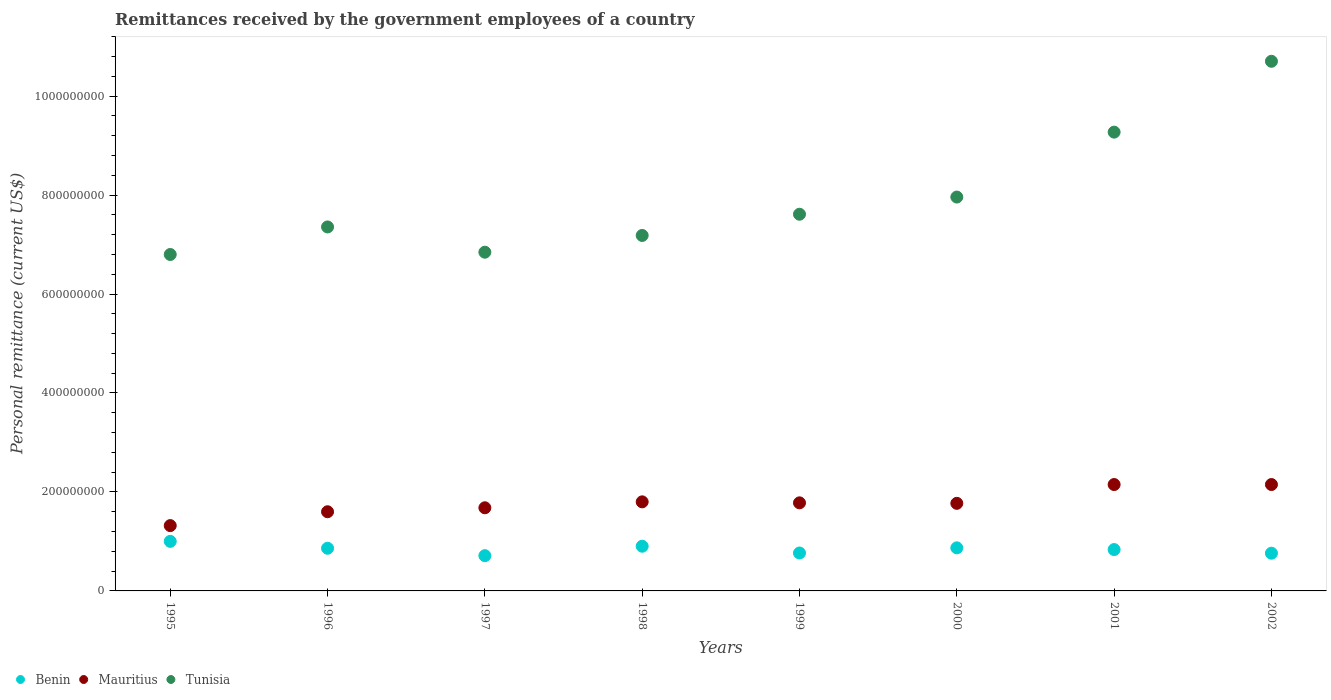How many different coloured dotlines are there?
Make the answer very short. 3. What is the remittances received by the government employees in Benin in 1998?
Offer a very short reply. 9.03e+07. Across all years, what is the maximum remittances received by the government employees in Mauritius?
Offer a terse response. 2.15e+08. Across all years, what is the minimum remittances received by the government employees in Mauritius?
Make the answer very short. 1.32e+08. In which year was the remittances received by the government employees in Benin minimum?
Make the answer very short. 1997. What is the total remittances received by the government employees in Mauritius in the graph?
Your response must be concise. 1.42e+09. What is the difference between the remittances received by the government employees in Tunisia in 1997 and that in 2001?
Keep it short and to the point. -2.43e+08. What is the difference between the remittances received by the government employees in Benin in 1995 and the remittances received by the government employees in Tunisia in 1996?
Offer a very short reply. -6.35e+08. What is the average remittances received by the government employees in Tunisia per year?
Make the answer very short. 7.97e+08. In the year 1998, what is the difference between the remittances received by the government employees in Mauritius and remittances received by the government employees in Tunisia?
Your answer should be compact. -5.38e+08. In how many years, is the remittances received by the government employees in Mauritius greater than 360000000 US$?
Offer a terse response. 0. What is the ratio of the remittances received by the government employees in Mauritius in 1995 to that in 1999?
Provide a succinct answer. 0.74. Is the difference between the remittances received by the government employees in Mauritius in 1999 and 2001 greater than the difference between the remittances received by the government employees in Tunisia in 1999 and 2001?
Your answer should be very brief. Yes. What is the difference between the highest and the second highest remittances received by the government employees in Benin?
Keep it short and to the point. 9.81e+06. What is the difference between the highest and the lowest remittances received by the government employees in Mauritius?
Offer a very short reply. 8.30e+07. In how many years, is the remittances received by the government employees in Benin greater than the average remittances received by the government employees in Benin taken over all years?
Offer a very short reply. 4. Is the remittances received by the government employees in Mauritius strictly greater than the remittances received by the government employees in Tunisia over the years?
Make the answer very short. No. Are the values on the major ticks of Y-axis written in scientific E-notation?
Ensure brevity in your answer.  No. Does the graph contain any zero values?
Give a very brief answer. No. Does the graph contain grids?
Offer a very short reply. No. Where does the legend appear in the graph?
Offer a very short reply. Bottom left. How many legend labels are there?
Offer a terse response. 3. How are the legend labels stacked?
Ensure brevity in your answer.  Horizontal. What is the title of the graph?
Offer a terse response. Remittances received by the government employees of a country. What is the label or title of the Y-axis?
Make the answer very short. Personal remittance (current US$). What is the Personal remittance (current US$) in Benin in 1995?
Offer a terse response. 1.00e+08. What is the Personal remittance (current US$) of Mauritius in 1995?
Offer a very short reply. 1.32e+08. What is the Personal remittance (current US$) of Tunisia in 1995?
Your answer should be compact. 6.80e+08. What is the Personal remittance (current US$) of Benin in 1996?
Your answer should be very brief. 8.62e+07. What is the Personal remittance (current US$) of Mauritius in 1996?
Keep it short and to the point. 1.60e+08. What is the Personal remittance (current US$) in Tunisia in 1996?
Make the answer very short. 7.36e+08. What is the Personal remittance (current US$) in Benin in 1997?
Give a very brief answer. 7.12e+07. What is the Personal remittance (current US$) of Mauritius in 1997?
Make the answer very short. 1.68e+08. What is the Personal remittance (current US$) of Tunisia in 1997?
Offer a very short reply. 6.85e+08. What is the Personal remittance (current US$) in Benin in 1998?
Offer a very short reply. 9.03e+07. What is the Personal remittance (current US$) in Mauritius in 1998?
Make the answer very short. 1.80e+08. What is the Personal remittance (current US$) in Tunisia in 1998?
Provide a short and direct response. 7.18e+08. What is the Personal remittance (current US$) in Benin in 1999?
Your answer should be very brief. 7.66e+07. What is the Personal remittance (current US$) of Mauritius in 1999?
Provide a short and direct response. 1.78e+08. What is the Personal remittance (current US$) in Tunisia in 1999?
Ensure brevity in your answer.  7.61e+08. What is the Personal remittance (current US$) in Benin in 2000?
Your answer should be compact. 8.71e+07. What is the Personal remittance (current US$) of Mauritius in 2000?
Provide a short and direct response. 1.77e+08. What is the Personal remittance (current US$) in Tunisia in 2000?
Make the answer very short. 7.96e+08. What is the Personal remittance (current US$) of Benin in 2001?
Your answer should be compact. 8.36e+07. What is the Personal remittance (current US$) of Mauritius in 2001?
Offer a very short reply. 2.15e+08. What is the Personal remittance (current US$) in Tunisia in 2001?
Your answer should be very brief. 9.27e+08. What is the Personal remittance (current US$) of Benin in 2002?
Your answer should be compact. 7.62e+07. What is the Personal remittance (current US$) of Mauritius in 2002?
Give a very brief answer. 2.15e+08. What is the Personal remittance (current US$) in Tunisia in 2002?
Your answer should be very brief. 1.07e+09. Across all years, what is the maximum Personal remittance (current US$) in Benin?
Offer a very short reply. 1.00e+08. Across all years, what is the maximum Personal remittance (current US$) in Mauritius?
Provide a short and direct response. 2.15e+08. Across all years, what is the maximum Personal remittance (current US$) of Tunisia?
Offer a very short reply. 1.07e+09. Across all years, what is the minimum Personal remittance (current US$) in Benin?
Give a very brief answer. 7.12e+07. Across all years, what is the minimum Personal remittance (current US$) of Mauritius?
Offer a terse response. 1.32e+08. Across all years, what is the minimum Personal remittance (current US$) in Tunisia?
Offer a very short reply. 6.80e+08. What is the total Personal remittance (current US$) in Benin in the graph?
Your answer should be compact. 6.71e+08. What is the total Personal remittance (current US$) in Mauritius in the graph?
Make the answer very short. 1.42e+09. What is the total Personal remittance (current US$) in Tunisia in the graph?
Offer a terse response. 6.37e+09. What is the difference between the Personal remittance (current US$) of Benin in 1995 and that in 1996?
Offer a terse response. 1.39e+07. What is the difference between the Personal remittance (current US$) in Mauritius in 1995 and that in 1996?
Your answer should be very brief. -2.80e+07. What is the difference between the Personal remittance (current US$) of Tunisia in 1995 and that in 1996?
Your answer should be very brief. -5.57e+07. What is the difference between the Personal remittance (current US$) in Benin in 1995 and that in 1997?
Offer a terse response. 2.89e+07. What is the difference between the Personal remittance (current US$) in Mauritius in 1995 and that in 1997?
Offer a very short reply. -3.60e+07. What is the difference between the Personal remittance (current US$) in Tunisia in 1995 and that in 1997?
Your response must be concise. -4.62e+06. What is the difference between the Personal remittance (current US$) of Benin in 1995 and that in 1998?
Give a very brief answer. 9.81e+06. What is the difference between the Personal remittance (current US$) of Mauritius in 1995 and that in 1998?
Offer a terse response. -4.80e+07. What is the difference between the Personal remittance (current US$) in Tunisia in 1995 and that in 1998?
Offer a very short reply. -3.85e+07. What is the difference between the Personal remittance (current US$) of Benin in 1995 and that in 1999?
Provide a short and direct response. 2.35e+07. What is the difference between the Personal remittance (current US$) of Mauritius in 1995 and that in 1999?
Your answer should be compact. -4.60e+07. What is the difference between the Personal remittance (current US$) in Tunisia in 1995 and that in 1999?
Ensure brevity in your answer.  -8.14e+07. What is the difference between the Personal remittance (current US$) in Benin in 1995 and that in 2000?
Your answer should be compact. 1.31e+07. What is the difference between the Personal remittance (current US$) in Mauritius in 1995 and that in 2000?
Give a very brief answer. -4.50e+07. What is the difference between the Personal remittance (current US$) of Tunisia in 1995 and that in 2000?
Make the answer very short. -1.16e+08. What is the difference between the Personal remittance (current US$) of Benin in 1995 and that in 2001?
Offer a terse response. 1.65e+07. What is the difference between the Personal remittance (current US$) in Mauritius in 1995 and that in 2001?
Offer a terse response. -8.30e+07. What is the difference between the Personal remittance (current US$) in Tunisia in 1995 and that in 2001?
Your response must be concise. -2.47e+08. What is the difference between the Personal remittance (current US$) of Benin in 1995 and that in 2002?
Make the answer very short. 2.39e+07. What is the difference between the Personal remittance (current US$) in Mauritius in 1995 and that in 2002?
Offer a very short reply. -8.30e+07. What is the difference between the Personal remittance (current US$) in Tunisia in 1995 and that in 2002?
Give a very brief answer. -3.90e+08. What is the difference between the Personal remittance (current US$) of Benin in 1996 and that in 1997?
Your answer should be compact. 1.50e+07. What is the difference between the Personal remittance (current US$) in Mauritius in 1996 and that in 1997?
Offer a very short reply. -8.00e+06. What is the difference between the Personal remittance (current US$) in Tunisia in 1996 and that in 1997?
Offer a terse response. 5.11e+07. What is the difference between the Personal remittance (current US$) of Benin in 1996 and that in 1998?
Offer a very short reply. -4.12e+06. What is the difference between the Personal remittance (current US$) of Mauritius in 1996 and that in 1998?
Your response must be concise. -2.00e+07. What is the difference between the Personal remittance (current US$) in Tunisia in 1996 and that in 1998?
Your response must be concise. 1.72e+07. What is the difference between the Personal remittance (current US$) of Benin in 1996 and that in 1999?
Your answer should be compact. 9.56e+06. What is the difference between the Personal remittance (current US$) of Mauritius in 1996 and that in 1999?
Offer a very short reply. -1.80e+07. What is the difference between the Personal remittance (current US$) in Tunisia in 1996 and that in 1999?
Ensure brevity in your answer.  -2.57e+07. What is the difference between the Personal remittance (current US$) in Benin in 1996 and that in 2000?
Keep it short and to the point. -8.57e+05. What is the difference between the Personal remittance (current US$) in Mauritius in 1996 and that in 2000?
Your answer should be very brief. -1.70e+07. What is the difference between the Personal remittance (current US$) of Tunisia in 1996 and that in 2000?
Your response must be concise. -6.04e+07. What is the difference between the Personal remittance (current US$) in Benin in 1996 and that in 2001?
Provide a short and direct response. 2.61e+06. What is the difference between the Personal remittance (current US$) in Mauritius in 1996 and that in 2001?
Offer a terse response. -5.50e+07. What is the difference between the Personal remittance (current US$) in Tunisia in 1996 and that in 2001?
Your answer should be compact. -1.92e+08. What is the difference between the Personal remittance (current US$) in Benin in 1996 and that in 2002?
Give a very brief answer. 9.98e+06. What is the difference between the Personal remittance (current US$) of Mauritius in 1996 and that in 2002?
Provide a short and direct response. -5.50e+07. What is the difference between the Personal remittance (current US$) in Tunisia in 1996 and that in 2002?
Provide a short and direct response. -3.35e+08. What is the difference between the Personal remittance (current US$) of Benin in 1997 and that in 1998?
Make the answer very short. -1.91e+07. What is the difference between the Personal remittance (current US$) of Mauritius in 1997 and that in 1998?
Your answer should be compact. -1.20e+07. What is the difference between the Personal remittance (current US$) in Tunisia in 1997 and that in 1998?
Give a very brief answer. -3.38e+07. What is the difference between the Personal remittance (current US$) of Benin in 1997 and that in 1999?
Make the answer very short. -5.41e+06. What is the difference between the Personal remittance (current US$) in Mauritius in 1997 and that in 1999?
Ensure brevity in your answer.  -1.00e+07. What is the difference between the Personal remittance (current US$) in Tunisia in 1997 and that in 1999?
Offer a very short reply. -7.67e+07. What is the difference between the Personal remittance (current US$) in Benin in 1997 and that in 2000?
Keep it short and to the point. -1.58e+07. What is the difference between the Personal remittance (current US$) of Mauritius in 1997 and that in 2000?
Offer a very short reply. -9.00e+06. What is the difference between the Personal remittance (current US$) in Tunisia in 1997 and that in 2000?
Ensure brevity in your answer.  -1.11e+08. What is the difference between the Personal remittance (current US$) in Benin in 1997 and that in 2001?
Provide a short and direct response. -1.24e+07. What is the difference between the Personal remittance (current US$) of Mauritius in 1997 and that in 2001?
Offer a very short reply. -4.70e+07. What is the difference between the Personal remittance (current US$) in Tunisia in 1997 and that in 2001?
Provide a succinct answer. -2.43e+08. What is the difference between the Personal remittance (current US$) in Benin in 1997 and that in 2002?
Keep it short and to the point. -4.99e+06. What is the difference between the Personal remittance (current US$) of Mauritius in 1997 and that in 2002?
Keep it short and to the point. -4.70e+07. What is the difference between the Personal remittance (current US$) in Tunisia in 1997 and that in 2002?
Give a very brief answer. -3.86e+08. What is the difference between the Personal remittance (current US$) in Benin in 1998 and that in 1999?
Provide a succinct answer. 1.37e+07. What is the difference between the Personal remittance (current US$) of Mauritius in 1998 and that in 1999?
Give a very brief answer. 2.00e+06. What is the difference between the Personal remittance (current US$) in Tunisia in 1998 and that in 1999?
Give a very brief answer. -4.29e+07. What is the difference between the Personal remittance (current US$) of Benin in 1998 and that in 2000?
Your answer should be compact. 3.26e+06. What is the difference between the Personal remittance (current US$) in Tunisia in 1998 and that in 2000?
Your answer should be very brief. -7.76e+07. What is the difference between the Personal remittance (current US$) in Benin in 1998 and that in 2001?
Provide a short and direct response. 6.72e+06. What is the difference between the Personal remittance (current US$) of Mauritius in 1998 and that in 2001?
Your response must be concise. -3.50e+07. What is the difference between the Personal remittance (current US$) in Tunisia in 1998 and that in 2001?
Provide a short and direct response. -2.09e+08. What is the difference between the Personal remittance (current US$) of Benin in 1998 and that in 2002?
Offer a terse response. 1.41e+07. What is the difference between the Personal remittance (current US$) of Mauritius in 1998 and that in 2002?
Offer a terse response. -3.50e+07. What is the difference between the Personal remittance (current US$) of Tunisia in 1998 and that in 2002?
Your response must be concise. -3.52e+08. What is the difference between the Personal remittance (current US$) in Benin in 1999 and that in 2000?
Offer a very short reply. -1.04e+07. What is the difference between the Personal remittance (current US$) of Tunisia in 1999 and that in 2000?
Make the answer very short. -3.47e+07. What is the difference between the Personal remittance (current US$) in Benin in 1999 and that in 2001?
Offer a terse response. -6.95e+06. What is the difference between the Personal remittance (current US$) in Mauritius in 1999 and that in 2001?
Provide a succinct answer. -3.70e+07. What is the difference between the Personal remittance (current US$) in Tunisia in 1999 and that in 2001?
Your answer should be very brief. -1.66e+08. What is the difference between the Personal remittance (current US$) of Benin in 1999 and that in 2002?
Offer a very short reply. 4.17e+05. What is the difference between the Personal remittance (current US$) in Mauritius in 1999 and that in 2002?
Offer a very short reply. -3.70e+07. What is the difference between the Personal remittance (current US$) of Tunisia in 1999 and that in 2002?
Your response must be concise. -3.09e+08. What is the difference between the Personal remittance (current US$) in Benin in 2000 and that in 2001?
Provide a succinct answer. 3.46e+06. What is the difference between the Personal remittance (current US$) of Mauritius in 2000 and that in 2001?
Your answer should be very brief. -3.80e+07. What is the difference between the Personal remittance (current US$) of Tunisia in 2000 and that in 2001?
Offer a terse response. -1.31e+08. What is the difference between the Personal remittance (current US$) of Benin in 2000 and that in 2002?
Offer a terse response. 1.08e+07. What is the difference between the Personal remittance (current US$) in Mauritius in 2000 and that in 2002?
Offer a very short reply. -3.80e+07. What is the difference between the Personal remittance (current US$) of Tunisia in 2000 and that in 2002?
Provide a short and direct response. -2.74e+08. What is the difference between the Personal remittance (current US$) in Benin in 2001 and that in 2002?
Offer a terse response. 7.37e+06. What is the difference between the Personal remittance (current US$) in Mauritius in 2001 and that in 2002?
Keep it short and to the point. 0. What is the difference between the Personal remittance (current US$) in Tunisia in 2001 and that in 2002?
Provide a succinct answer. -1.43e+08. What is the difference between the Personal remittance (current US$) of Benin in 1995 and the Personal remittance (current US$) of Mauritius in 1996?
Ensure brevity in your answer.  -5.99e+07. What is the difference between the Personal remittance (current US$) of Benin in 1995 and the Personal remittance (current US$) of Tunisia in 1996?
Offer a terse response. -6.35e+08. What is the difference between the Personal remittance (current US$) in Mauritius in 1995 and the Personal remittance (current US$) in Tunisia in 1996?
Your answer should be very brief. -6.04e+08. What is the difference between the Personal remittance (current US$) in Benin in 1995 and the Personal remittance (current US$) in Mauritius in 1997?
Provide a succinct answer. -6.79e+07. What is the difference between the Personal remittance (current US$) in Benin in 1995 and the Personal remittance (current US$) in Tunisia in 1997?
Make the answer very short. -5.84e+08. What is the difference between the Personal remittance (current US$) of Mauritius in 1995 and the Personal remittance (current US$) of Tunisia in 1997?
Offer a very short reply. -5.53e+08. What is the difference between the Personal remittance (current US$) in Benin in 1995 and the Personal remittance (current US$) in Mauritius in 1998?
Provide a succinct answer. -7.99e+07. What is the difference between the Personal remittance (current US$) in Benin in 1995 and the Personal remittance (current US$) in Tunisia in 1998?
Your response must be concise. -6.18e+08. What is the difference between the Personal remittance (current US$) of Mauritius in 1995 and the Personal remittance (current US$) of Tunisia in 1998?
Give a very brief answer. -5.86e+08. What is the difference between the Personal remittance (current US$) in Benin in 1995 and the Personal remittance (current US$) in Mauritius in 1999?
Provide a short and direct response. -7.79e+07. What is the difference between the Personal remittance (current US$) in Benin in 1995 and the Personal remittance (current US$) in Tunisia in 1999?
Give a very brief answer. -6.61e+08. What is the difference between the Personal remittance (current US$) of Mauritius in 1995 and the Personal remittance (current US$) of Tunisia in 1999?
Keep it short and to the point. -6.29e+08. What is the difference between the Personal remittance (current US$) of Benin in 1995 and the Personal remittance (current US$) of Mauritius in 2000?
Give a very brief answer. -7.69e+07. What is the difference between the Personal remittance (current US$) of Benin in 1995 and the Personal remittance (current US$) of Tunisia in 2000?
Your answer should be very brief. -6.96e+08. What is the difference between the Personal remittance (current US$) in Mauritius in 1995 and the Personal remittance (current US$) in Tunisia in 2000?
Provide a succinct answer. -6.64e+08. What is the difference between the Personal remittance (current US$) of Benin in 1995 and the Personal remittance (current US$) of Mauritius in 2001?
Your response must be concise. -1.15e+08. What is the difference between the Personal remittance (current US$) of Benin in 1995 and the Personal remittance (current US$) of Tunisia in 2001?
Offer a terse response. -8.27e+08. What is the difference between the Personal remittance (current US$) of Mauritius in 1995 and the Personal remittance (current US$) of Tunisia in 2001?
Your response must be concise. -7.95e+08. What is the difference between the Personal remittance (current US$) in Benin in 1995 and the Personal remittance (current US$) in Mauritius in 2002?
Keep it short and to the point. -1.15e+08. What is the difference between the Personal remittance (current US$) in Benin in 1995 and the Personal remittance (current US$) in Tunisia in 2002?
Provide a short and direct response. -9.70e+08. What is the difference between the Personal remittance (current US$) in Mauritius in 1995 and the Personal remittance (current US$) in Tunisia in 2002?
Make the answer very short. -9.38e+08. What is the difference between the Personal remittance (current US$) in Benin in 1996 and the Personal remittance (current US$) in Mauritius in 1997?
Offer a very short reply. -8.18e+07. What is the difference between the Personal remittance (current US$) in Benin in 1996 and the Personal remittance (current US$) in Tunisia in 1997?
Keep it short and to the point. -5.98e+08. What is the difference between the Personal remittance (current US$) of Mauritius in 1996 and the Personal remittance (current US$) of Tunisia in 1997?
Your answer should be very brief. -5.25e+08. What is the difference between the Personal remittance (current US$) of Benin in 1996 and the Personal remittance (current US$) of Mauritius in 1998?
Offer a terse response. -9.38e+07. What is the difference between the Personal remittance (current US$) of Benin in 1996 and the Personal remittance (current US$) of Tunisia in 1998?
Offer a very short reply. -6.32e+08. What is the difference between the Personal remittance (current US$) in Mauritius in 1996 and the Personal remittance (current US$) in Tunisia in 1998?
Your response must be concise. -5.58e+08. What is the difference between the Personal remittance (current US$) in Benin in 1996 and the Personal remittance (current US$) in Mauritius in 1999?
Your answer should be very brief. -9.18e+07. What is the difference between the Personal remittance (current US$) of Benin in 1996 and the Personal remittance (current US$) of Tunisia in 1999?
Give a very brief answer. -6.75e+08. What is the difference between the Personal remittance (current US$) in Mauritius in 1996 and the Personal remittance (current US$) in Tunisia in 1999?
Give a very brief answer. -6.01e+08. What is the difference between the Personal remittance (current US$) of Benin in 1996 and the Personal remittance (current US$) of Mauritius in 2000?
Ensure brevity in your answer.  -9.08e+07. What is the difference between the Personal remittance (current US$) of Benin in 1996 and the Personal remittance (current US$) of Tunisia in 2000?
Ensure brevity in your answer.  -7.10e+08. What is the difference between the Personal remittance (current US$) in Mauritius in 1996 and the Personal remittance (current US$) in Tunisia in 2000?
Ensure brevity in your answer.  -6.36e+08. What is the difference between the Personal remittance (current US$) in Benin in 1996 and the Personal remittance (current US$) in Mauritius in 2001?
Your answer should be very brief. -1.29e+08. What is the difference between the Personal remittance (current US$) of Benin in 1996 and the Personal remittance (current US$) of Tunisia in 2001?
Give a very brief answer. -8.41e+08. What is the difference between the Personal remittance (current US$) of Mauritius in 1996 and the Personal remittance (current US$) of Tunisia in 2001?
Provide a succinct answer. -7.67e+08. What is the difference between the Personal remittance (current US$) of Benin in 1996 and the Personal remittance (current US$) of Mauritius in 2002?
Make the answer very short. -1.29e+08. What is the difference between the Personal remittance (current US$) in Benin in 1996 and the Personal remittance (current US$) in Tunisia in 2002?
Provide a succinct answer. -9.84e+08. What is the difference between the Personal remittance (current US$) of Mauritius in 1996 and the Personal remittance (current US$) of Tunisia in 2002?
Offer a very short reply. -9.10e+08. What is the difference between the Personal remittance (current US$) in Benin in 1997 and the Personal remittance (current US$) in Mauritius in 1998?
Provide a short and direct response. -1.09e+08. What is the difference between the Personal remittance (current US$) of Benin in 1997 and the Personal remittance (current US$) of Tunisia in 1998?
Keep it short and to the point. -6.47e+08. What is the difference between the Personal remittance (current US$) of Mauritius in 1997 and the Personal remittance (current US$) of Tunisia in 1998?
Give a very brief answer. -5.50e+08. What is the difference between the Personal remittance (current US$) in Benin in 1997 and the Personal remittance (current US$) in Mauritius in 1999?
Provide a succinct answer. -1.07e+08. What is the difference between the Personal remittance (current US$) of Benin in 1997 and the Personal remittance (current US$) of Tunisia in 1999?
Offer a terse response. -6.90e+08. What is the difference between the Personal remittance (current US$) in Mauritius in 1997 and the Personal remittance (current US$) in Tunisia in 1999?
Your answer should be very brief. -5.93e+08. What is the difference between the Personal remittance (current US$) of Benin in 1997 and the Personal remittance (current US$) of Mauritius in 2000?
Your response must be concise. -1.06e+08. What is the difference between the Personal remittance (current US$) in Benin in 1997 and the Personal remittance (current US$) in Tunisia in 2000?
Provide a succinct answer. -7.25e+08. What is the difference between the Personal remittance (current US$) of Mauritius in 1997 and the Personal remittance (current US$) of Tunisia in 2000?
Your answer should be very brief. -6.28e+08. What is the difference between the Personal remittance (current US$) of Benin in 1997 and the Personal remittance (current US$) of Mauritius in 2001?
Your answer should be very brief. -1.44e+08. What is the difference between the Personal remittance (current US$) of Benin in 1997 and the Personal remittance (current US$) of Tunisia in 2001?
Provide a short and direct response. -8.56e+08. What is the difference between the Personal remittance (current US$) in Mauritius in 1997 and the Personal remittance (current US$) in Tunisia in 2001?
Offer a very short reply. -7.59e+08. What is the difference between the Personal remittance (current US$) in Benin in 1997 and the Personal remittance (current US$) in Mauritius in 2002?
Keep it short and to the point. -1.44e+08. What is the difference between the Personal remittance (current US$) of Benin in 1997 and the Personal remittance (current US$) of Tunisia in 2002?
Offer a very short reply. -9.99e+08. What is the difference between the Personal remittance (current US$) of Mauritius in 1997 and the Personal remittance (current US$) of Tunisia in 2002?
Your answer should be compact. -9.02e+08. What is the difference between the Personal remittance (current US$) in Benin in 1998 and the Personal remittance (current US$) in Mauritius in 1999?
Your answer should be compact. -8.77e+07. What is the difference between the Personal remittance (current US$) in Benin in 1998 and the Personal remittance (current US$) in Tunisia in 1999?
Offer a very short reply. -6.71e+08. What is the difference between the Personal remittance (current US$) of Mauritius in 1998 and the Personal remittance (current US$) of Tunisia in 1999?
Your answer should be compact. -5.81e+08. What is the difference between the Personal remittance (current US$) of Benin in 1998 and the Personal remittance (current US$) of Mauritius in 2000?
Your answer should be very brief. -8.67e+07. What is the difference between the Personal remittance (current US$) in Benin in 1998 and the Personal remittance (current US$) in Tunisia in 2000?
Provide a succinct answer. -7.06e+08. What is the difference between the Personal remittance (current US$) in Mauritius in 1998 and the Personal remittance (current US$) in Tunisia in 2000?
Offer a terse response. -6.16e+08. What is the difference between the Personal remittance (current US$) of Benin in 1998 and the Personal remittance (current US$) of Mauritius in 2001?
Provide a short and direct response. -1.25e+08. What is the difference between the Personal remittance (current US$) of Benin in 1998 and the Personal remittance (current US$) of Tunisia in 2001?
Your answer should be very brief. -8.37e+08. What is the difference between the Personal remittance (current US$) in Mauritius in 1998 and the Personal remittance (current US$) in Tunisia in 2001?
Offer a very short reply. -7.47e+08. What is the difference between the Personal remittance (current US$) in Benin in 1998 and the Personal remittance (current US$) in Mauritius in 2002?
Offer a terse response. -1.25e+08. What is the difference between the Personal remittance (current US$) in Benin in 1998 and the Personal remittance (current US$) in Tunisia in 2002?
Ensure brevity in your answer.  -9.80e+08. What is the difference between the Personal remittance (current US$) in Mauritius in 1998 and the Personal remittance (current US$) in Tunisia in 2002?
Ensure brevity in your answer.  -8.90e+08. What is the difference between the Personal remittance (current US$) in Benin in 1999 and the Personal remittance (current US$) in Mauritius in 2000?
Provide a short and direct response. -1.00e+08. What is the difference between the Personal remittance (current US$) in Benin in 1999 and the Personal remittance (current US$) in Tunisia in 2000?
Your response must be concise. -7.19e+08. What is the difference between the Personal remittance (current US$) of Mauritius in 1999 and the Personal remittance (current US$) of Tunisia in 2000?
Give a very brief answer. -6.18e+08. What is the difference between the Personal remittance (current US$) of Benin in 1999 and the Personal remittance (current US$) of Mauritius in 2001?
Ensure brevity in your answer.  -1.38e+08. What is the difference between the Personal remittance (current US$) of Benin in 1999 and the Personal remittance (current US$) of Tunisia in 2001?
Provide a short and direct response. -8.51e+08. What is the difference between the Personal remittance (current US$) in Mauritius in 1999 and the Personal remittance (current US$) in Tunisia in 2001?
Make the answer very short. -7.49e+08. What is the difference between the Personal remittance (current US$) in Benin in 1999 and the Personal remittance (current US$) in Mauritius in 2002?
Your answer should be compact. -1.38e+08. What is the difference between the Personal remittance (current US$) of Benin in 1999 and the Personal remittance (current US$) of Tunisia in 2002?
Provide a short and direct response. -9.94e+08. What is the difference between the Personal remittance (current US$) of Mauritius in 1999 and the Personal remittance (current US$) of Tunisia in 2002?
Give a very brief answer. -8.92e+08. What is the difference between the Personal remittance (current US$) in Benin in 2000 and the Personal remittance (current US$) in Mauritius in 2001?
Your answer should be very brief. -1.28e+08. What is the difference between the Personal remittance (current US$) in Benin in 2000 and the Personal remittance (current US$) in Tunisia in 2001?
Ensure brevity in your answer.  -8.40e+08. What is the difference between the Personal remittance (current US$) of Mauritius in 2000 and the Personal remittance (current US$) of Tunisia in 2001?
Offer a terse response. -7.50e+08. What is the difference between the Personal remittance (current US$) of Benin in 2000 and the Personal remittance (current US$) of Mauritius in 2002?
Offer a very short reply. -1.28e+08. What is the difference between the Personal remittance (current US$) of Benin in 2000 and the Personal remittance (current US$) of Tunisia in 2002?
Offer a terse response. -9.83e+08. What is the difference between the Personal remittance (current US$) of Mauritius in 2000 and the Personal remittance (current US$) of Tunisia in 2002?
Your answer should be very brief. -8.93e+08. What is the difference between the Personal remittance (current US$) in Benin in 2001 and the Personal remittance (current US$) in Mauritius in 2002?
Your answer should be very brief. -1.31e+08. What is the difference between the Personal remittance (current US$) in Benin in 2001 and the Personal remittance (current US$) in Tunisia in 2002?
Your answer should be compact. -9.87e+08. What is the difference between the Personal remittance (current US$) in Mauritius in 2001 and the Personal remittance (current US$) in Tunisia in 2002?
Your response must be concise. -8.55e+08. What is the average Personal remittance (current US$) in Benin per year?
Ensure brevity in your answer.  8.39e+07. What is the average Personal remittance (current US$) of Mauritius per year?
Make the answer very short. 1.78e+08. What is the average Personal remittance (current US$) in Tunisia per year?
Your response must be concise. 7.97e+08. In the year 1995, what is the difference between the Personal remittance (current US$) of Benin and Personal remittance (current US$) of Mauritius?
Provide a short and direct response. -3.19e+07. In the year 1995, what is the difference between the Personal remittance (current US$) in Benin and Personal remittance (current US$) in Tunisia?
Offer a terse response. -5.80e+08. In the year 1995, what is the difference between the Personal remittance (current US$) in Mauritius and Personal remittance (current US$) in Tunisia?
Keep it short and to the point. -5.48e+08. In the year 1996, what is the difference between the Personal remittance (current US$) in Benin and Personal remittance (current US$) in Mauritius?
Provide a succinct answer. -7.38e+07. In the year 1996, what is the difference between the Personal remittance (current US$) in Benin and Personal remittance (current US$) in Tunisia?
Your response must be concise. -6.49e+08. In the year 1996, what is the difference between the Personal remittance (current US$) of Mauritius and Personal remittance (current US$) of Tunisia?
Offer a very short reply. -5.76e+08. In the year 1997, what is the difference between the Personal remittance (current US$) in Benin and Personal remittance (current US$) in Mauritius?
Give a very brief answer. -9.68e+07. In the year 1997, what is the difference between the Personal remittance (current US$) of Benin and Personal remittance (current US$) of Tunisia?
Give a very brief answer. -6.13e+08. In the year 1997, what is the difference between the Personal remittance (current US$) of Mauritius and Personal remittance (current US$) of Tunisia?
Ensure brevity in your answer.  -5.17e+08. In the year 1998, what is the difference between the Personal remittance (current US$) of Benin and Personal remittance (current US$) of Mauritius?
Your answer should be compact. -8.97e+07. In the year 1998, what is the difference between the Personal remittance (current US$) in Benin and Personal remittance (current US$) in Tunisia?
Offer a very short reply. -6.28e+08. In the year 1998, what is the difference between the Personal remittance (current US$) in Mauritius and Personal remittance (current US$) in Tunisia?
Your response must be concise. -5.38e+08. In the year 1999, what is the difference between the Personal remittance (current US$) of Benin and Personal remittance (current US$) of Mauritius?
Your answer should be very brief. -1.01e+08. In the year 1999, what is the difference between the Personal remittance (current US$) of Benin and Personal remittance (current US$) of Tunisia?
Provide a succinct answer. -6.85e+08. In the year 1999, what is the difference between the Personal remittance (current US$) of Mauritius and Personal remittance (current US$) of Tunisia?
Provide a short and direct response. -5.83e+08. In the year 2000, what is the difference between the Personal remittance (current US$) of Benin and Personal remittance (current US$) of Mauritius?
Provide a succinct answer. -8.99e+07. In the year 2000, what is the difference between the Personal remittance (current US$) of Benin and Personal remittance (current US$) of Tunisia?
Provide a short and direct response. -7.09e+08. In the year 2000, what is the difference between the Personal remittance (current US$) in Mauritius and Personal remittance (current US$) in Tunisia?
Ensure brevity in your answer.  -6.19e+08. In the year 2001, what is the difference between the Personal remittance (current US$) in Benin and Personal remittance (current US$) in Mauritius?
Your answer should be very brief. -1.31e+08. In the year 2001, what is the difference between the Personal remittance (current US$) of Benin and Personal remittance (current US$) of Tunisia?
Keep it short and to the point. -8.44e+08. In the year 2001, what is the difference between the Personal remittance (current US$) in Mauritius and Personal remittance (current US$) in Tunisia?
Ensure brevity in your answer.  -7.12e+08. In the year 2002, what is the difference between the Personal remittance (current US$) in Benin and Personal remittance (current US$) in Mauritius?
Provide a succinct answer. -1.39e+08. In the year 2002, what is the difference between the Personal remittance (current US$) in Benin and Personal remittance (current US$) in Tunisia?
Your answer should be very brief. -9.94e+08. In the year 2002, what is the difference between the Personal remittance (current US$) of Mauritius and Personal remittance (current US$) of Tunisia?
Offer a very short reply. -8.55e+08. What is the ratio of the Personal remittance (current US$) of Benin in 1995 to that in 1996?
Make the answer very short. 1.16. What is the ratio of the Personal remittance (current US$) of Mauritius in 1995 to that in 1996?
Offer a very short reply. 0.82. What is the ratio of the Personal remittance (current US$) in Tunisia in 1995 to that in 1996?
Your answer should be compact. 0.92. What is the ratio of the Personal remittance (current US$) of Benin in 1995 to that in 1997?
Make the answer very short. 1.41. What is the ratio of the Personal remittance (current US$) of Mauritius in 1995 to that in 1997?
Provide a short and direct response. 0.79. What is the ratio of the Personal remittance (current US$) of Tunisia in 1995 to that in 1997?
Offer a very short reply. 0.99. What is the ratio of the Personal remittance (current US$) in Benin in 1995 to that in 1998?
Keep it short and to the point. 1.11. What is the ratio of the Personal remittance (current US$) in Mauritius in 1995 to that in 1998?
Give a very brief answer. 0.73. What is the ratio of the Personal remittance (current US$) in Tunisia in 1995 to that in 1998?
Offer a very short reply. 0.95. What is the ratio of the Personal remittance (current US$) in Benin in 1995 to that in 1999?
Keep it short and to the point. 1.31. What is the ratio of the Personal remittance (current US$) in Mauritius in 1995 to that in 1999?
Provide a short and direct response. 0.74. What is the ratio of the Personal remittance (current US$) of Tunisia in 1995 to that in 1999?
Your response must be concise. 0.89. What is the ratio of the Personal remittance (current US$) in Benin in 1995 to that in 2000?
Provide a short and direct response. 1.15. What is the ratio of the Personal remittance (current US$) in Mauritius in 1995 to that in 2000?
Provide a succinct answer. 0.75. What is the ratio of the Personal remittance (current US$) of Tunisia in 1995 to that in 2000?
Give a very brief answer. 0.85. What is the ratio of the Personal remittance (current US$) in Benin in 1995 to that in 2001?
Your response must be concise. 1.2. What is the ratio of the Personal remittance (current US$) in Mauritius in 1995 to that in 2001?
Make the answer very short. 0.61. What is the ratio of the Personal remittance (current US$) of Tunisia in 1995 to that in 2001?
Offer a very short reply. 0.73. What is the ratio of the Personal remittance (current US$) in Benin in 1995 to that in 2002?
Ensure brevity in your answer.  1.31. What is the ratio of the Personal remittance (current US$) in Mauritius in 1995 to that in 2002?
Provide a succinct answer. 0.61. What is the ratio of the Personal remittance (current US$) of Tunisia in 1995 to that in 2002?
Make the answer very short. 0.64. What is the ratio of the Personal remittance (current US$) in Benin in 1996 to that in 1997?
Give a very brief answer. 1.21. What is the ratio of the Personal remittance (current US$) in Mauritius in 1996 to that in 1997?
Give a very brief answer. 0.95. What is the ratio of the Personal remittance (current US$) in Tunisia in 1996 to that in 1997?
Provide a succinct answer. 1.07. What is the ratio of the Personal remittance (current US$) of Benin in 1996 to that in 1998?
Provide a short and direct response. 0.95. What is the ratio of the Personal remittance (current US$) in Tunisia in 1996 to that in 1998?
Keep it short and to the point. 1.02. What is the ratio of the Personal remittance (current US$) of Benin in 1996 to that in 1999?
Your answer should be compact. 1.12. What is the ratio of the Personal remittance (current US$) in Mauritius in 1996 to that in 1999?
Your answer should be very brief. 0.9. What is the ratio of the Personal remittance (current US$) in Tunisia in 1996 to that in 1999?
Give a very brief answer. 0.97. What is the ratio of the Personal remittance (current US$) in Benin in 1996 to that in 2000?
Provide a succinct answer. 0.99. What is the ratio of the Personal remittance (current US$) of Mauritius in 1996 to that in 2000?
Provide a succinct answer. 0.9. What is the ratio of the Personal remittance (current US$) of Tunisia in 1996 to that in 2000?
Provide a short and direct response. 0.92. What is the ratio of the Personal remittance (current US$) in Benin in 1996 to that in 2001?
Ensure brevity in your answer.  1.03. What is the ratio of the Personal remittance (current US$) in Mauritius in 1996 to that in 2001?
Your response must be concise. 0.74. What is the ratio of the Personal remittance (current US$) of Tunisia in 1996 to that in 2001?
Give a very brief answer. 0.79. What is the ratio of the Personal remittance (current US$) of Benin in 1996 to that in 2002?
Your response must be concise. 1.13. What is the ratio of the Personal remittance (current US$) of Mauritius in 1996 to that in 2002?
Your response must be concise. 0.74. What is the ratio of the Personal remittance (current US$) in Tunisia in 1996 to that in 2002?
Your answer should be compact. 0.69. What is the ratio of the Personal remittance (current US$) of Benin in 1997 to that in 1998?
Keep it short and to the point. 0.79. What is the ratio of the Personal remittance (current US$) of Tunisia in 1997 to that in 1998?
Offer a very short reply. 0.95. What is the ratio of the Personal remittance (current US$) of Benin in 1997 to that in 1999?
Make the answer very short. 0.93. What is the ratio of the Personal remittance (current US$) of Mauritius in 1997 to that in 1999?
Ensure brevity in your answer.  0.94. What is the ratio of the Personal remittance (current US$) in Tunisia in 1997 to that in 1999?
Offer a very short reply. 0.9. What is the ratio of the Personal remittance (current US$) in Benin in 1997 to that in 2000?
Give a very brief answer. 0.82. What is the ratio of the Personal remittance (current US$) in Mauritius in 1997 to that in 2000?
Offer a terse response. 0.95. What is the ratio of the Personal remittance (current US$) of Tunisia in 1997 to that in 2000?
Give a very brief answer. 0.86. What is the ratio of the Personal remittance (current US$) in Benin in 1997 to that in 2001?
Offer a very short reply. 0.85. What is the ratio of the Personal remittance (current US$) in Mauritius in 1997 to that in 2001?
Keep it short and to the point. 0.78. What is the ratio of the Personal remittance (current US$) in Tunisia in 1997 to that in 2001?
Keep it short and to the point. 0.74. What is the ratio of the Personal remittance (current US$) in Benin in 1997 to that in 2002?
Offer a very short reply. 0.93. What is the ratio of the Personal remittance (current US$) of Mauritius in 1997 to that in 2002?
Ensure brevity in your answer.  0.78. What is the ratio of the Personal remittance (current US$) in Tunisia in 1997 to that in 2002?
Offer a terse response. 0.64. What is the ratio of the Personal remittance (current US$) in Benin in 1998 to that in 1999?
Keep it short and to the point. 1.18. What is the ratio of the Personal remittance (current US$) of Mauritius in 1998 to that in 1999?
Keep it short and to the point. 1.01. What is the ratio of the Personal remittance (current US$) in Tunisia in 1998 to that in 1999?
Provide a short and direct response. 0.94. What is the ratio of the Personal remittance (current US$) of Benin in 1998 to that in 2000?
Make the answer very short. 1.04. What is the ratio of the Personal remittance (current US$) of Mauritius in 1998 to that in 2000?
Your answer should be very brief. 1.02. What is the ratio of the Personal remittance (current US$) of Tunisia in 1998 to that in 2000?
Your answer should be very brief. 0.9. What is the ratio of the Personal remittance (current US$) of Benin in 1998 to that in 2001?
Make the answer very short. 1.08. What is the ratio of the Personal remittance (current US$) in Mauritius in 1998 to that in 2001?
Offer a very short reply. 0.84. What is the ratio of the Personal remittance (current US$) in Tunisia in 1998 to that in 2001?
Provide a short and direct response. 0.77. What is the ratio of the Personal remittance (current US$) of Benin in 1998 to that in 2002?
Your response must be concise. 1.18. What is the ratio of the Personal remittance (current US$) in Mauritius in 1998 to that in 2002?
Your answer should be very brief. 0.84. What is the ratio of the Personal remittance (current US$) of Tunisia in 1998 to that in 2002?
Make the answer very short. 0.67. What is the ratio of the Personal remittance (current US$) of Benin in 1999 to that in 2000?
Your answer should be compact. 0.88. What is the ratio of the Personal remittance (current US$) of Mauritius in 1999 to that in 2000?
Your answer should be compact. 1.01. What is the ratio of the Personal remittance (current US$) of Tunisia in 1999 to that in 2000?
Offer a very short reply. 0.96. What is the ratio of the Personal remittance (current US$) of Benin in 1999 to that in 2001?
Provide a short and direct response. 0.92. What is the ratio of the Personal remittance (current US$) in Mauritius in 1999 to that in 2001?
Ensure brevity in your answer.  0.83. What is the ratio of the Personal remittance (current US$) of Tunisia in 1999 to that in 2001?
Your response must be concise. 0.82. What is the ratio of the Personal remittance (current US$) of Mauritius in 1999 to that in 2002?
Provide a succinct answer. 0.83. What is the ratio of the Personal remittance (current US$) of Tunisia in 1999 to that in 2002?
Ensure brevity in your answer.  0.71. What is the ratio of the Personal remittance (current US$) in Benin in 2000 to that in 2001?
Your answer should be compact. 1.04. What is the ratio of the Personal remittance (current US$) of Mauritius in 2000 to that in 2001?
Your answer should be very brief. 0.82. What is the ratio of the Personal remittance (current US$) of Tunisia in 2000 to that in 2001?
Provide a short and direct response. 0.86. What is the ratio of the Personal remittance (current US$) of Benin in 2000 to that in 2002?
Provide a short and direct response. 1.14. What is the ratio of the Personal remittance (current US$) of Mauritius in 2000 to that in 2002?
Provide a succinct answer. 0.82. What is the ratio of the Personal remittance (current US$) of Tunisia in 2000 to that in 2002?
Your response must be concise. 0.74. What is the ratio of the Personal remittance (current US$) of Benin in 2001 to that in 2002?
Keep it short and to the point. 1.1. What is the ratio of the Personal remittance (current US$) of Tunisia in 2001 to that in 2002?
Keep it short and to the point. 0.87. What is the difference between the highest and the second highest Personal remittance (current US$) of Benin?
Give a very brief answer. 9.81e+06. What is the difference between the highest and the second highest Personal remittance (current US$) in Mauritius?
Your response must be concise. 0. What is the difference between the highest and the second highest Personal remittance (current US$) in Tunisia?
Offer a very short reply. 1.43e+08. What is the difference between the highest and the lowest Personal remittance (current US$) of Benin?
Make the answer very short. 2.89e+07. What is the difference between the highest and the lowest Personal remittance (current US$) in Mauritius?
Ensure brevity in your answer.  8.30e+07. What is the difference between the highest and the lowest Personal remittance (current US$) in Tunisia?
Your answer should be very brief. 3.90e+08. 